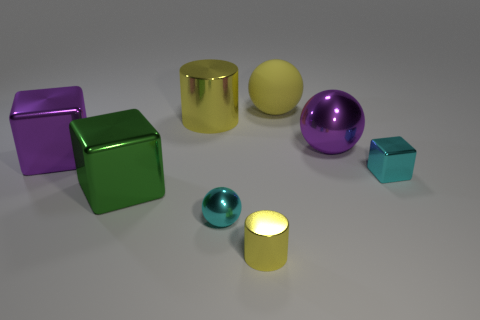Add 1 tiny yellow cylinders. How many objects exist? 9 Subtract all cubes. How many objects are left? 5 Add 1 purple metal balls. How many purple metal balls exist? 2 Subtract 0 blue spheres. How many objects are left? 8 Subtract all large metallic things. Subtract all tiny cyan cylinders. How many objects are left? 4 Add 8 cyan shiny balls. How many cyan shiny balls are left? 9 